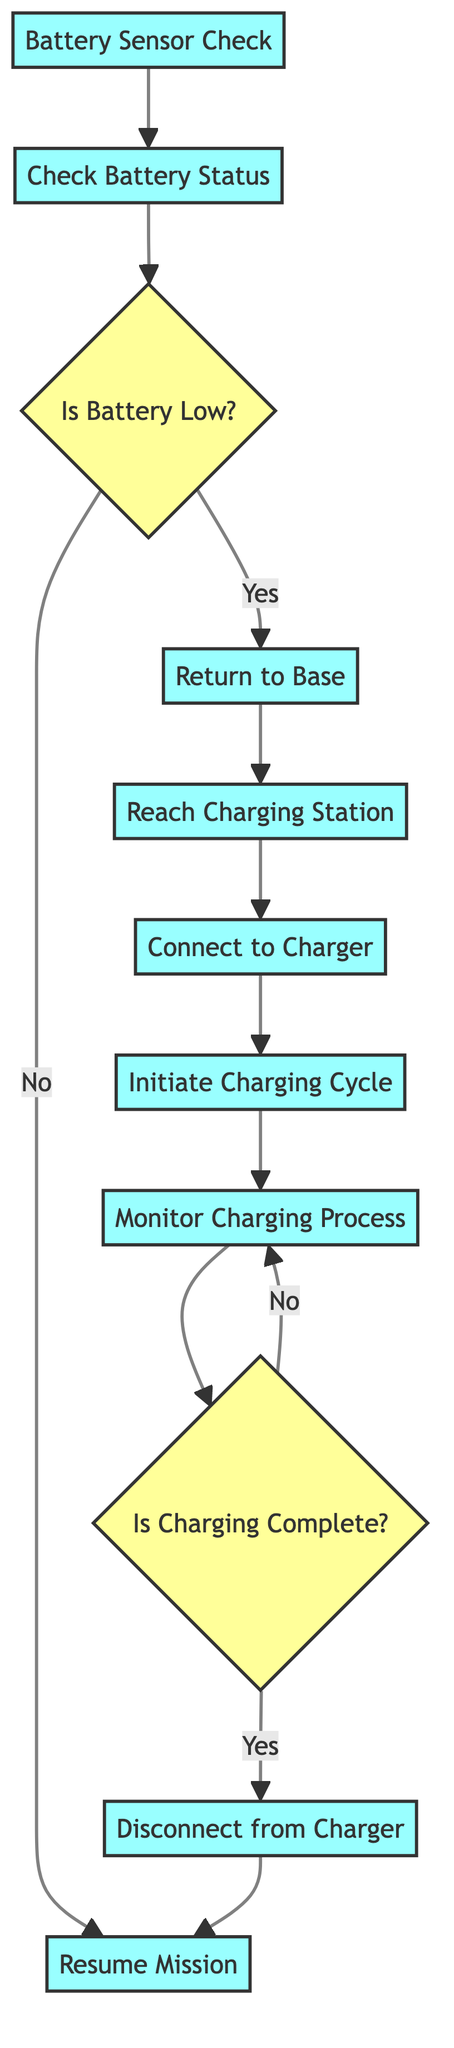What is the initial step in the battery management routine? The first step is the "Battery Sensor Check", where initial checks are performed to ensure the battery health and monitoring sensors are functioning properly.
Answer: Battery Sensor Check How many decision points are present in the diagram? The diagram features two decision points: "Is Battery Low?" and "Is Charging Complete?" which guide the flow of the routine based on battery status and charging progress.
Answer: 2 What happens if the battery level is not low? If the battery level is not low, the drone resumes its mission and moves directly to the "Resume Mission" step after checking the battery status.
Answer: Resume Mission At which step does the charging process begin? The charging process begins at the "Initiate Charging Cycle" step, which starts the charging with appropriate settings based on battery type and health status.
Answer: Initiate Charging Cycle What must occur after the drone is fully charged? Once the drone is fully charged, it must "Disconnect from Charger" to safely end the charging process before proceeding.
Answer: Disconnect from Charger If the battery is low, what is the next action to take? If the battery is low, the next action is to "Return to Base" to initiate the protocol for recharging the drone.
Answer: Return to Base What is monitored during the charging process? During the charging process, "Monitor Charging Process" occurs to prevent issues such as overheating or overcharging of the drone’s battery.
Answer: Monitor Charging Process Which step indicates whether the battery is fully charged? The step that indicates whether the battery is fully charged is "Is Charging Complete?", which is a decision point in the charging process.
Answer: Is Charging Complete What happens in the event of an incomplete charging cycle? If the charging cycle is incomplete, the flow returns to the "Monitor Charging Process", continuing until charging is finished.
Answer: Monitor Charging Process 